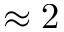<formula> <loc_0><loc_0><loc_500><loc_500>\approx 2</formula> 